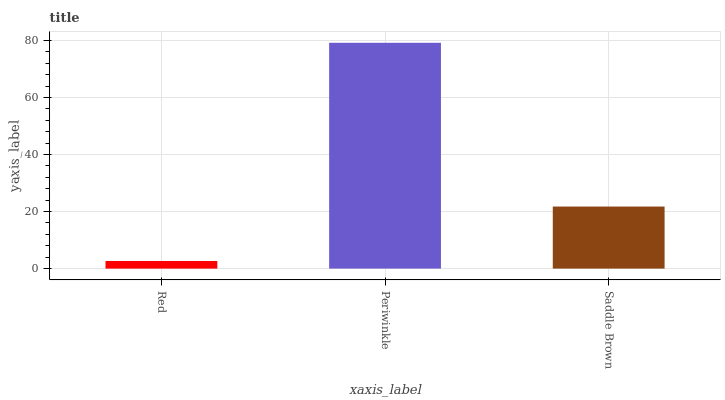Is Red the minimum?
Answer yes or no. Yes. Is Periwinkle the maximum?
Answer yes or no. Yes. Is Saddle Brown the minimum?
Answer yes or no. No. Is Saddle Brown the maximum?
Answer yes or no. No. Is Periwinkle greater than Saddle Brown?
Answer yes or no. Yes. Is Saddle Brown less than Periwinkle?
Answer yes or no. Yes. Is Saddle Brown greater than Periwinkle?
Answer yes or no. No. Is Periwinkle less than Saddle Brown?
Answer yes or no. No. Is Saddle Brown the high median?
Answer yes or no. Yes. Is Saddle Brown the low median?
Answer yes or no. Yes. Is Red the high median?
Answer yes or no. No. Is Red the low median?
Answer yes or no. No. 